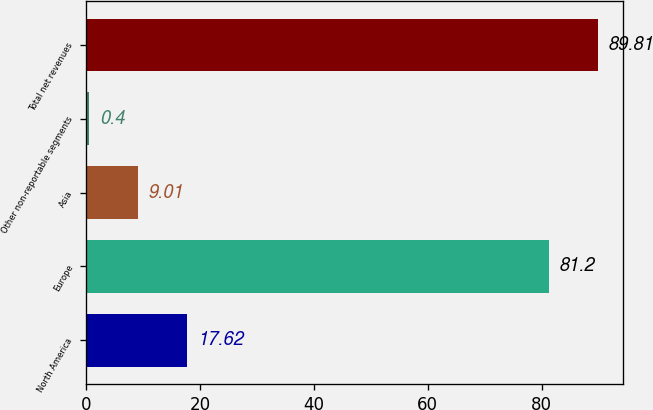<chart> <loc_0><loc_0><loc_500><loc_500><bar_chart><fcel>North America<fcel>Europe<fcel>Asia<fcel>Other non-reportable segments<fcel>Total net revenues<nl><fcel>17.62<fcel>81.2<fcel>9.01<fcel>0.4<fcel>89.81<nl></chart> 